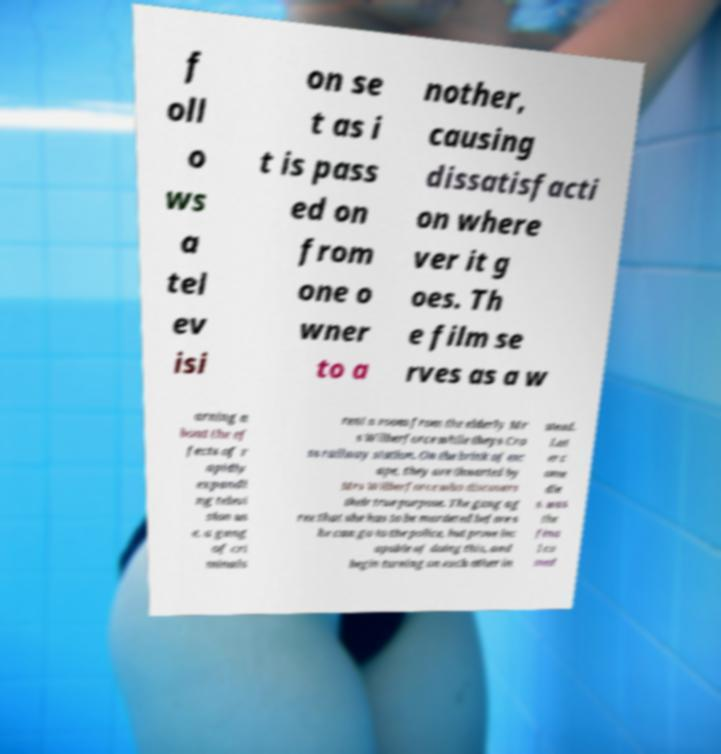What messages or text are displayed in this image? I need them in a readable, typed format. f oll o ws a tel ev isi on se t as i t is pass ed on from one o wner to a nother, causing dissatisfacti on where ver it g oes. Th e film se rves as a w arning a bout the ef fects of r apidly expandi ng televi sion us e. a gang of cri minals rent a room from the elderly Mr s Wilberforce while theys Cro ss railway station. On the brink of esc ape, they are thwarted by Mrs Wilberforce who discovers their true purpose. The gang ag ree that she has to be murdered before s he can go to the police, but prove inc apable of doing this, and begin turning on each other in stead. Lat er c ome die s. was the fina l co med 